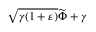<formula> <loc_0><loc_0><loc_500><loc_500>\sqrt { \gamma ( 1 + \varepsilon ) } { \widetilde { \Phi } } + \gamma</formula> 